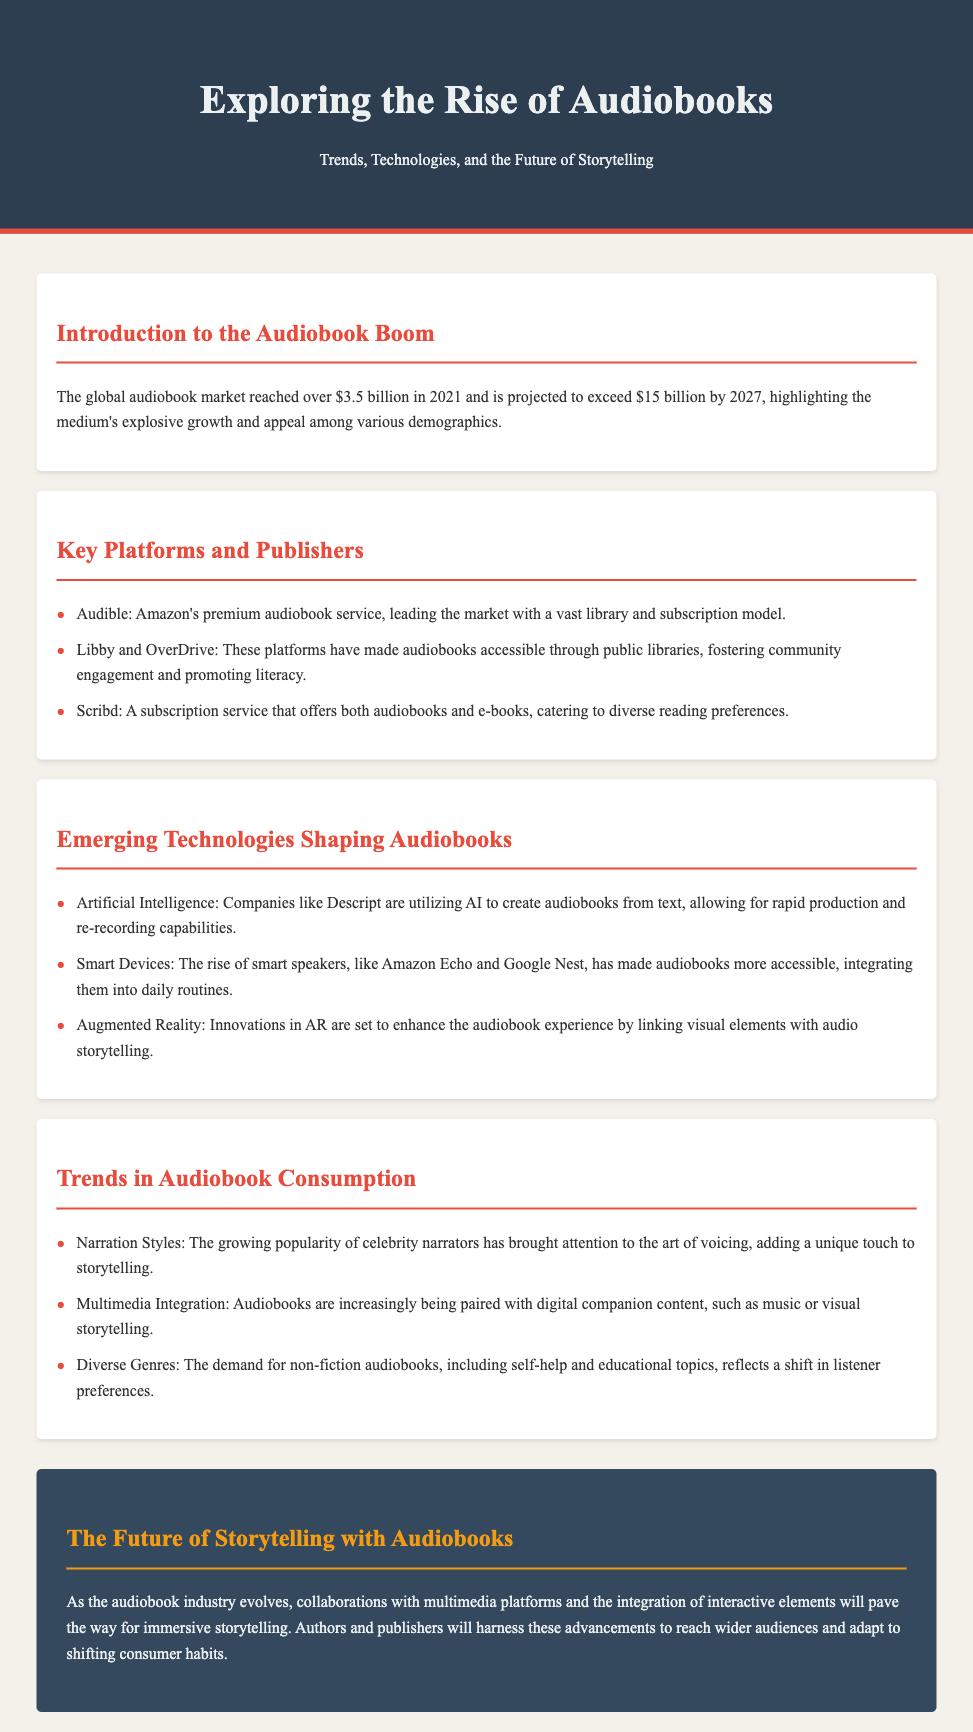What is the global audiobook market value in 2021? The document states that the global audiobook market reached over $3.5 billion in 2021.
Answer: $3.5 billion What is the projected value of the audiobook market by 2027? The document indicates that the market is projected to exceed $15 billion by 2027.
Answer: $15 billion Which company leads the audiobook market? The document mentions that Audible, Amazon's premium audiobook service, leads the market.
Answer: Audible What are two platforms mentioned that provide access to audiobooks through libraries? The document specifies Libby and OverDrive as platforms that have made audiobooks accessible through public libraries.
Answer: Libby and OverDrive What technology is used by Descript to create audiobooks? The document states that companies like Descript are utilizing Artificial Intelligence to create audiobooks from text.
Answer: Artificial Intelligence What is a trend in audiobook consumption related to narration? The document notes that the growing popularity of celebrity narrators has brought attention to the art of voicing.
Answer: Celebrity narrators How is the future of storytelling expected to evolve, according to the document? The document reflects that collaborations with multimedia platforms and interactive elements will enhance immersive storytelling.
Answer: Collaborations and interactive elements What genre is seeing increased demand in audiobooks? The document mentions that the demand for non-fiction audiobooks reflects a shift in listener preferences.
Answer: Non-fiction Which smart devices have made audiobooks more accessible? The document names smart speakers like Amazon Echo and Google Nest as devices increasing accessibility to audiobooks.
Answer: Amazon Echo and Google Nest 